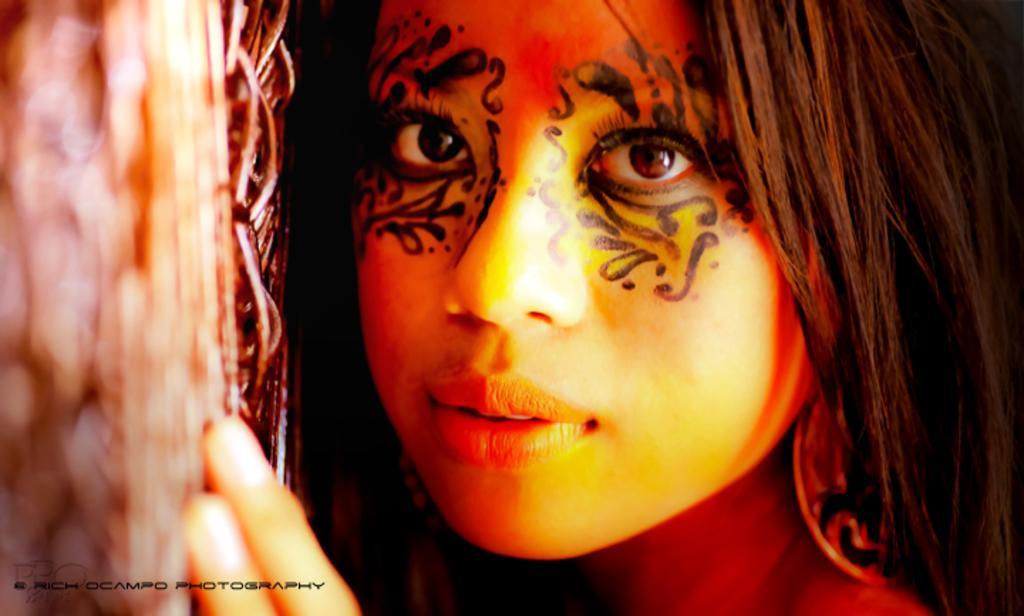Please provide a concise description of this image. In the image there is a lady face. On the face there is some design around the eyes. On the left corner of the image there is an object. In the bottom left corner of the image there is a name. 